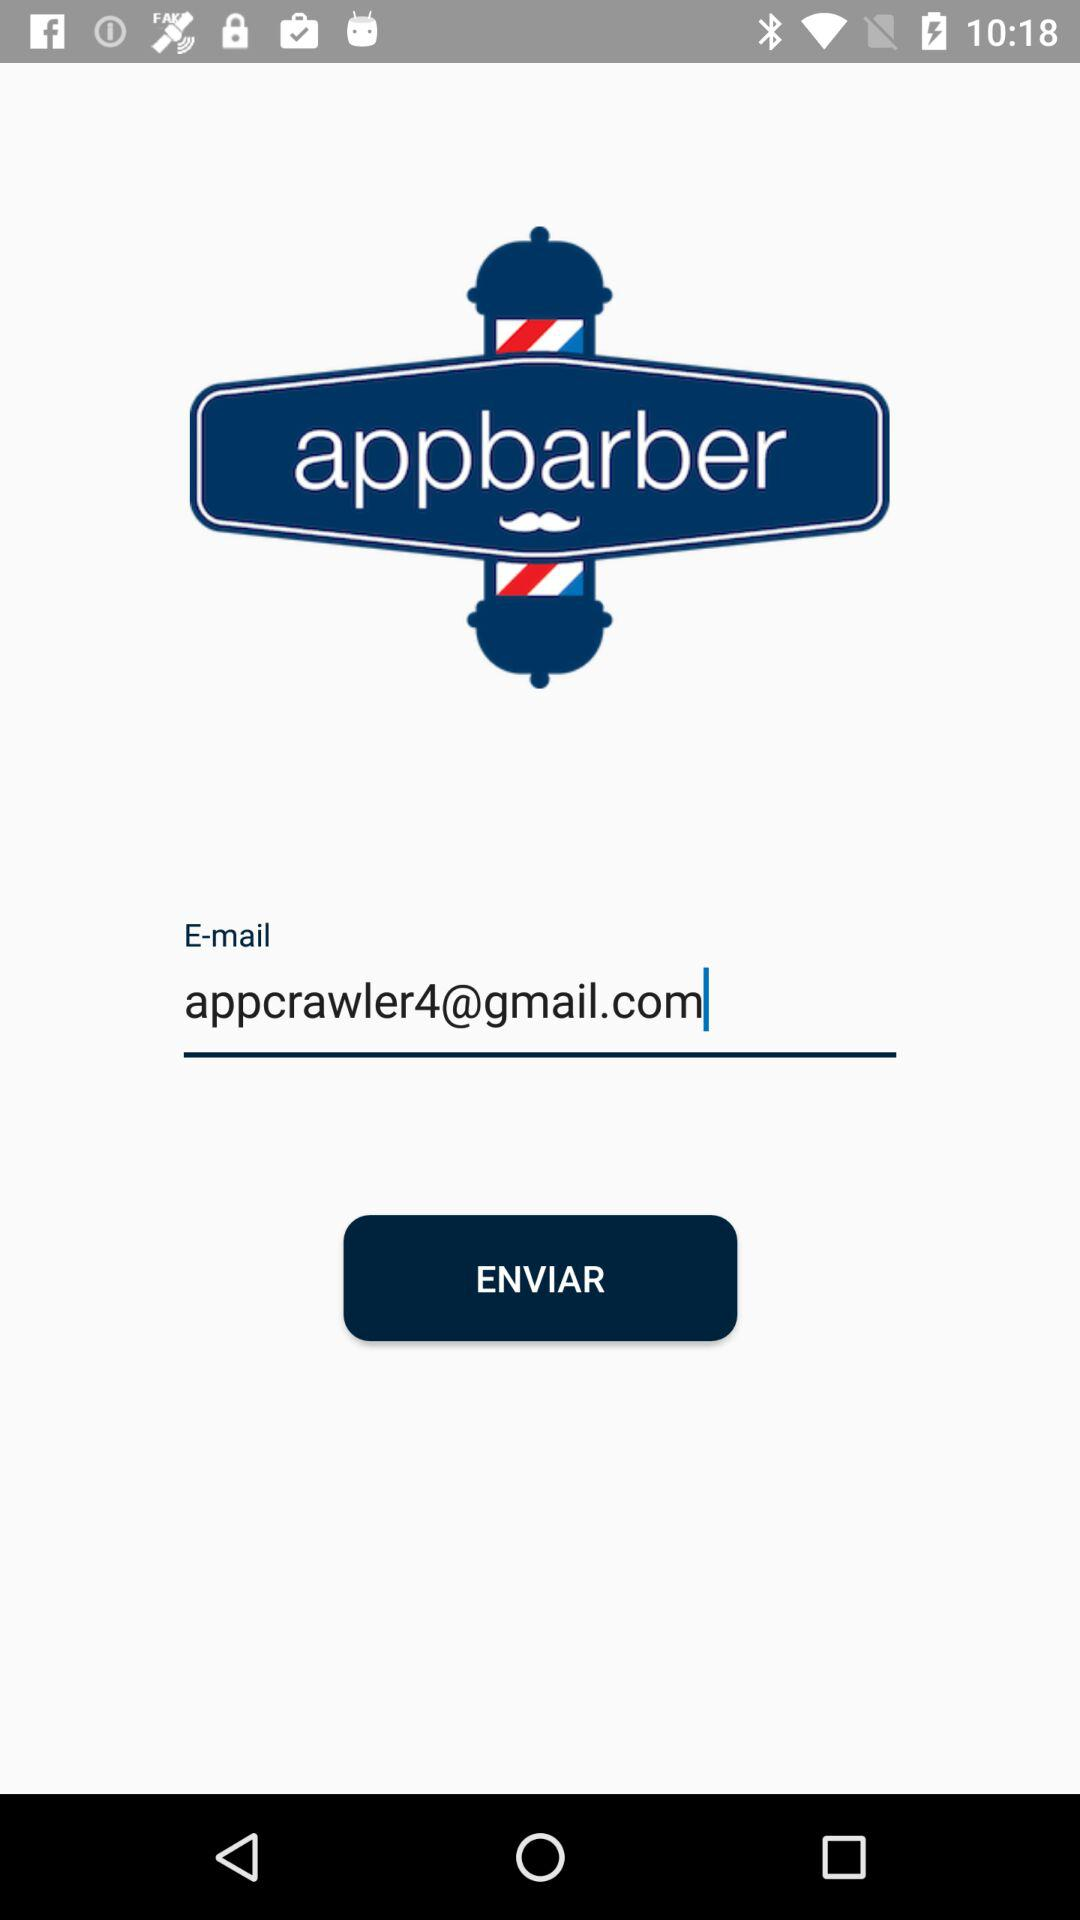What is the email address? The email address is appcrawler4@gmail.com. 